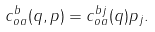<formula> <loc_0><loc_0><loc_500><loc_500>c _ { o a } ^ { b } ( q , p ) = c _ { o a } ^ { b j } ( q ) p _ { j } .</formula> 